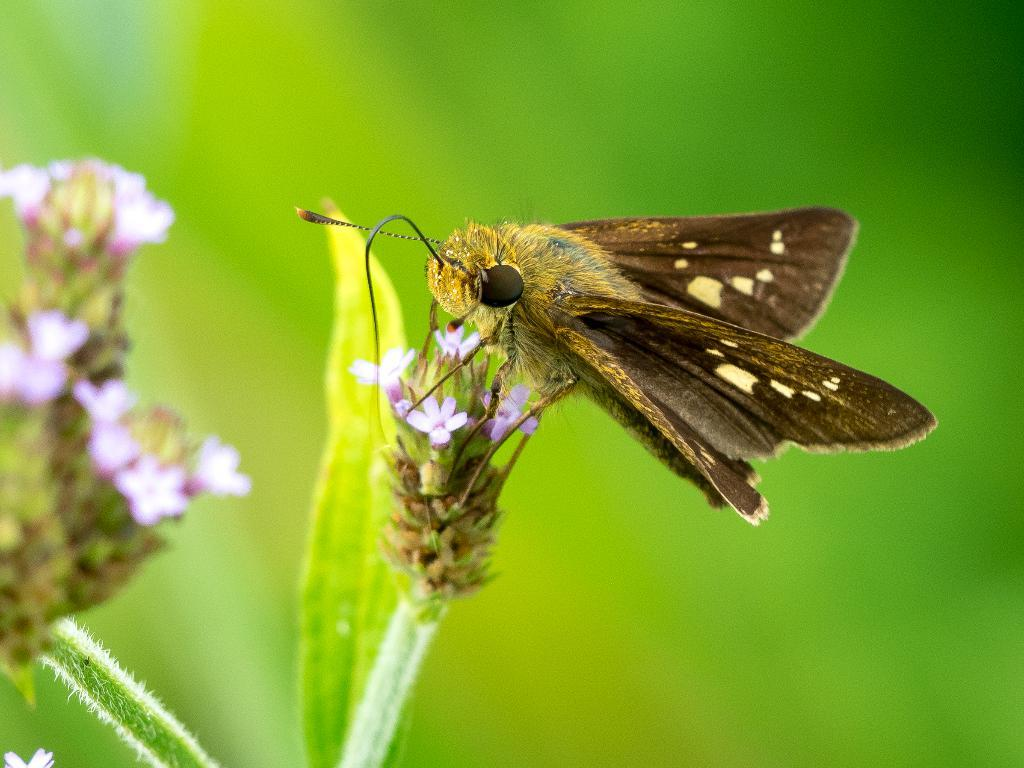What is the main subject of the image? There is a butterfly in the image. Where is the butterfly located in the image? The butterfly is sitting on a flower. Can you describe the flower the butterfly is on? The flower has a leaf and stem. What is the color or tone of the background in the image? The background of the image is greenish and blurred. What type of toy can be seen in the image? There is no toy present in the image; it features a butterfly sitting on a flower. Can you describe the patch on the butterfly's wing? There is no patch visible on the butterfly's wing in the image. 